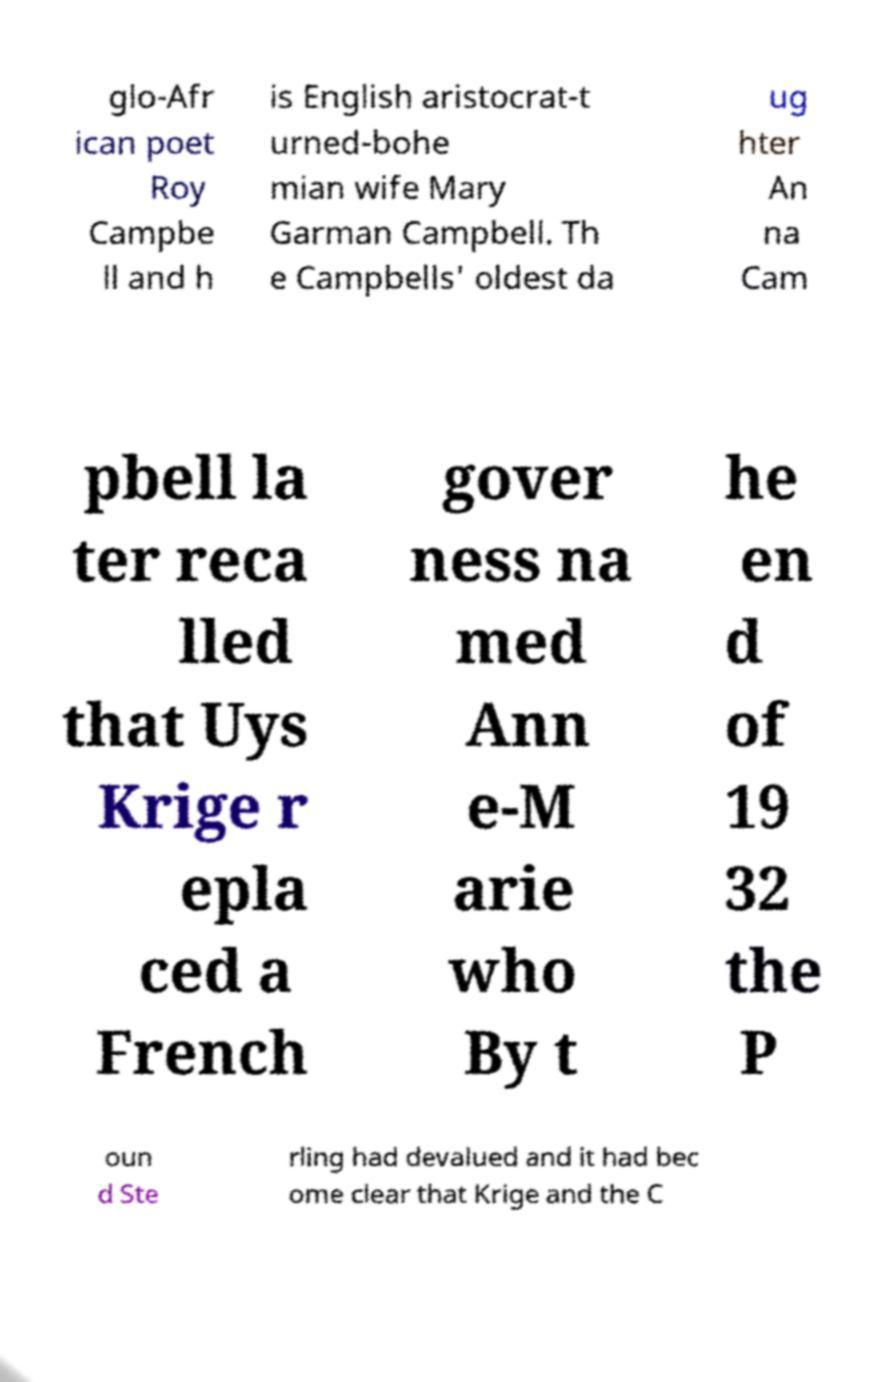There's text embedded in this image that I need extracted. Can you transcribe it verbatim? glo-Afr ican poet Roy Campbe ll and h is English aristocrat-t urned-bohe mian wife Mary Garman Campbell. Th e Campbells' oldest da ug hter An na Cam pbell la ter reca lled that Uys Krige r epla ced a French gover ness na med Ann e-M arie who By t he en d of 19 32 the P oun d Ste rling had devalued and it had bec ome clear that Krige and the C 